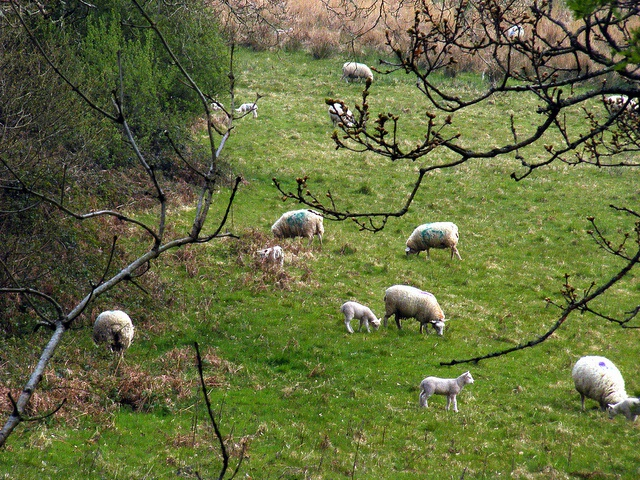Describe the objects in this image and their specific colors. I can see sheep in black, white, gray, and darkgreen tones, sheep in black, white, gray, and darkgray tones, sheep in black, gray, darkgreen, and lightgray tones, sheep in black, white, gray, and darkgreen tones, and sheep in black, white, gray, and darkgreen tones in this image. 